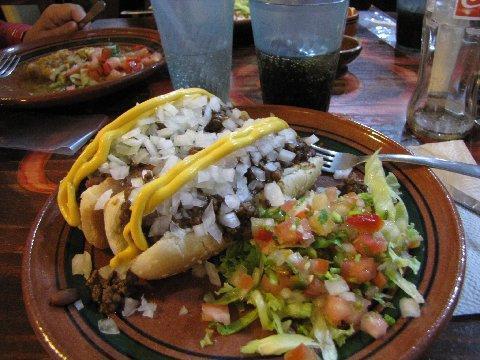How many dining tables are there?
Give a very brief answer. 2. How many cups are in the picture?
Give a very brief answer. 2. 